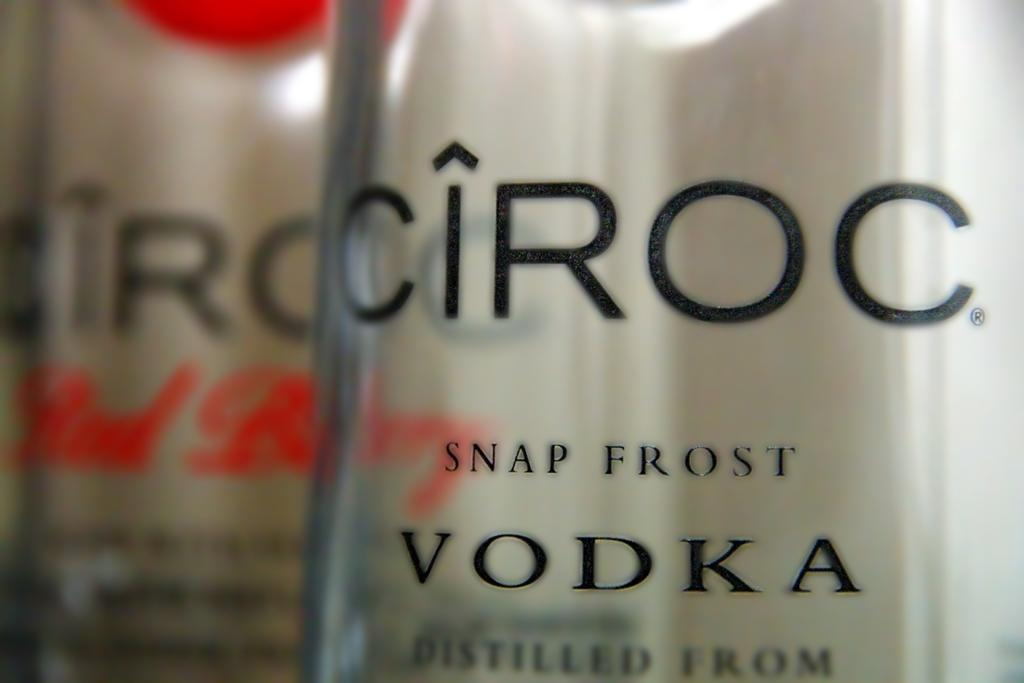<image>
Share a concise interpretation of the image provided. the word Vodka is on the item that has snap frost on it 